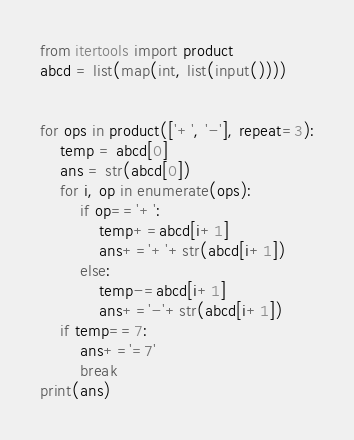Convert code to text. <code><loc_0><loc_0><loc_500><loc_500><_Python_>from itertools import product
abcd = list(map(int, list(input())))


for ops in product(['+', '-'], repeat=3):
    temp = abcd[0]
    ans = str(abcd[0])
    for i, op in enumerate(ops):
        if op=='+':
            temp+=abcd[i+1]
            ans+='+'+str(abcd[i+1])
        else:
            temp-=abcd[i+1]
            ans+='-'+str(abcd[i+1])
    if temp==7:
        ans+='=7'
        break
print(ans)</code> 